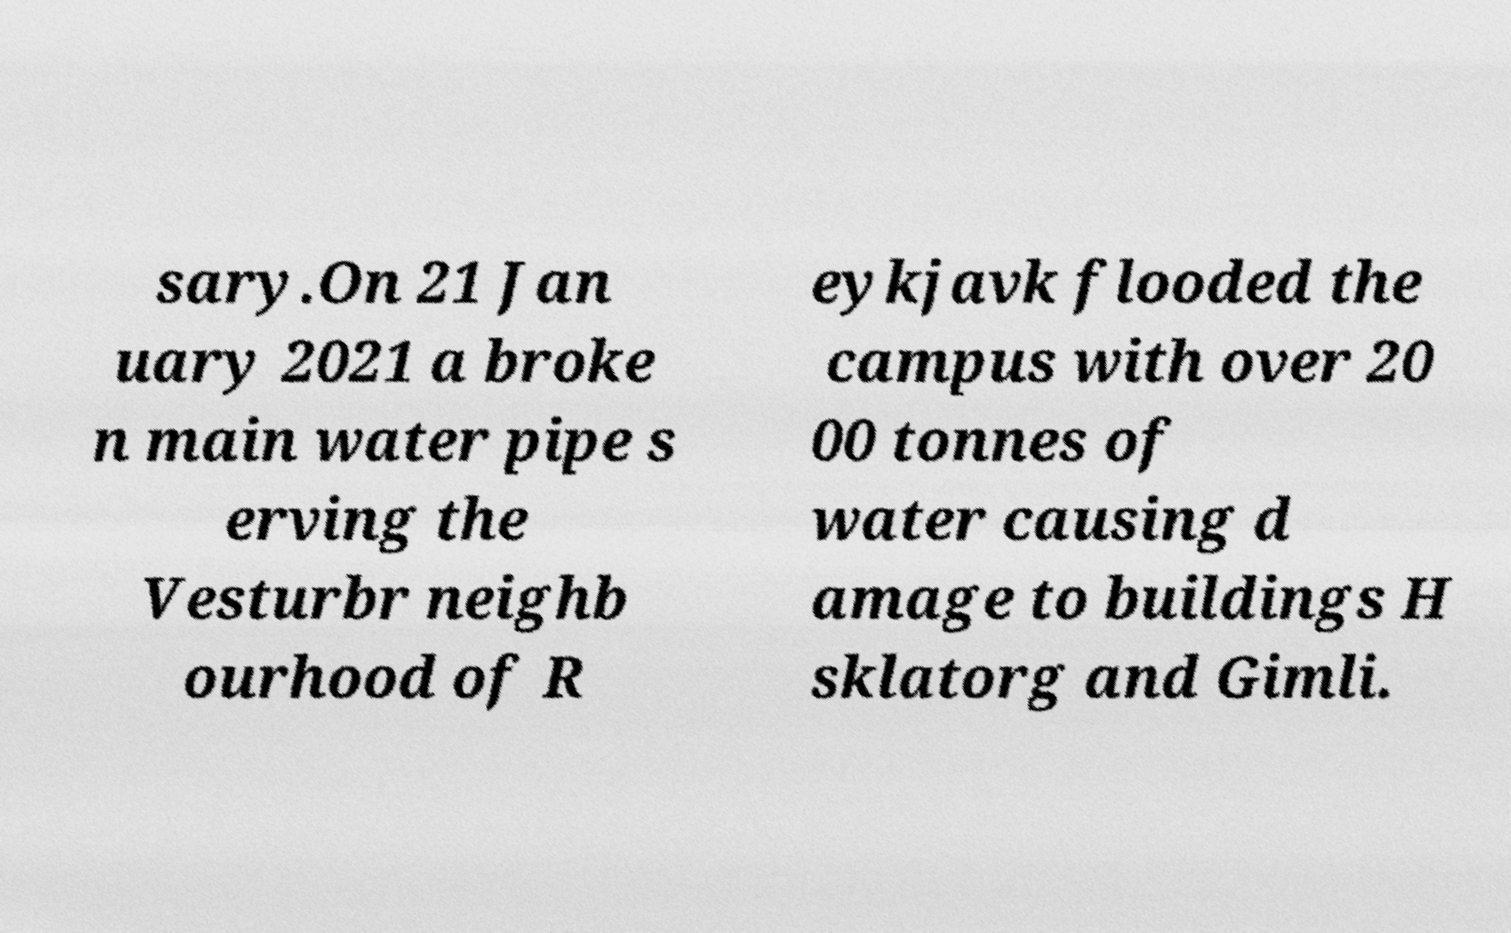I need the written content from this picture converted into text. Can you do that? sary.On 21 Jan uary 2021 a broke n main water pipe s erving the Vesturbr neighb ourhood of R eykjavk flooded the campus with over 20 00 tonnes of water causing d amage to buildings H sklatorg and Gimli. 